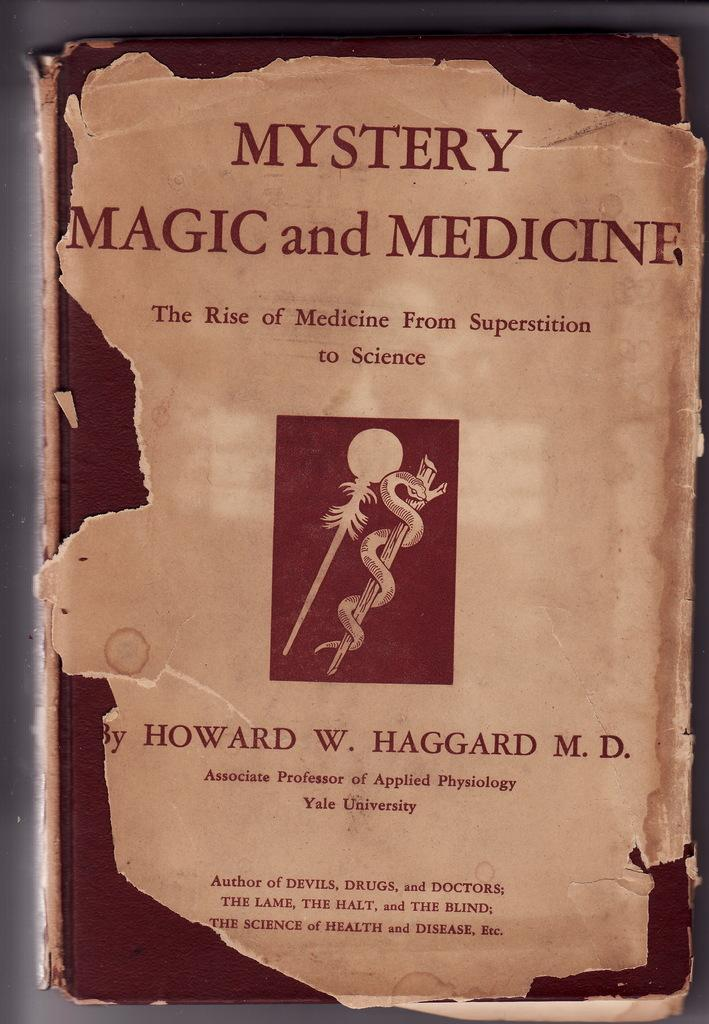Provide a one-sentence caption for the provided image. The front cover of a book about magic and medicine is torn around the edges. 